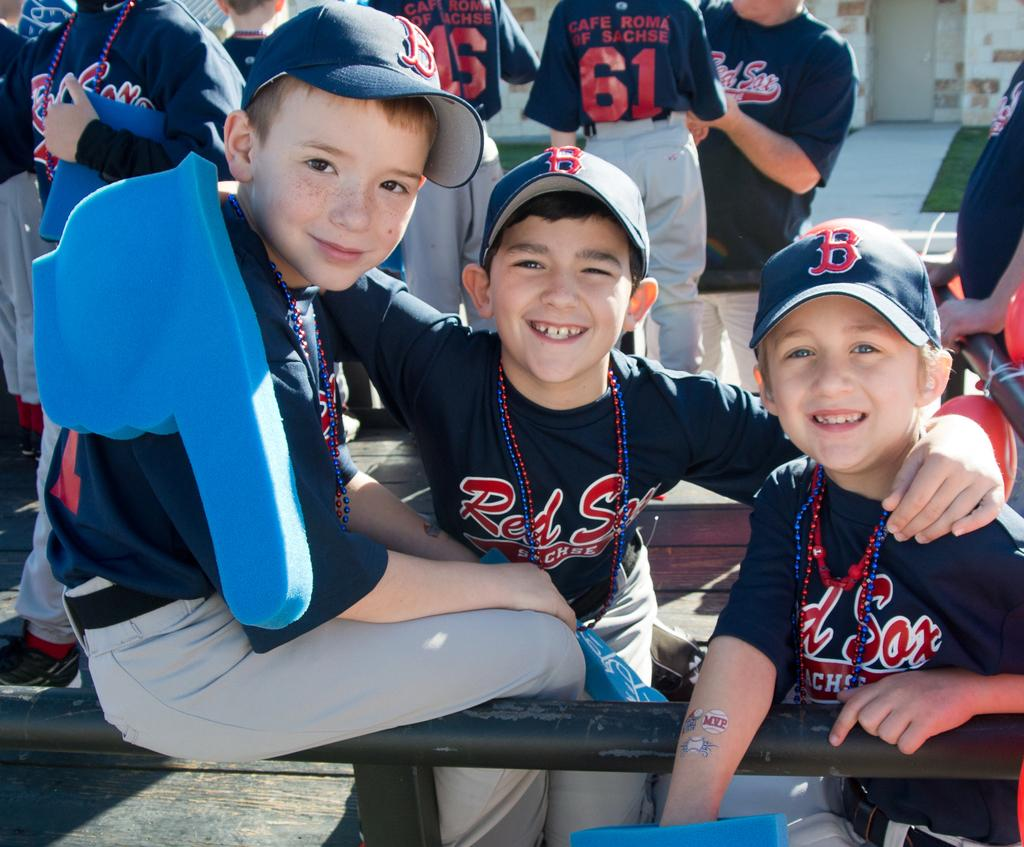<image>
Render a clear and concise summary of the photo. The kids here are wearing clothing from the Red Sox 